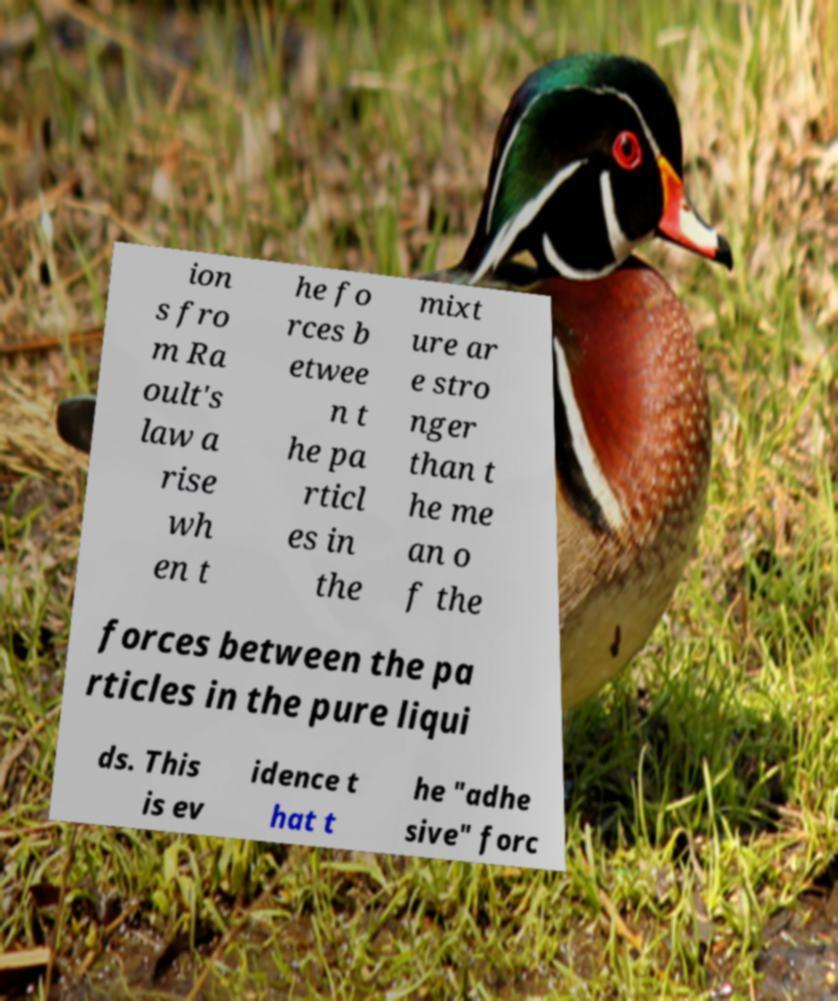Please identify and transcribe the text found in this image. ion s fro m Ra oult's law a rise wh en t he fo rces b etwee n t he pa rticl es in the mixt ure ar e stro nger than t he me an o f the forces between the pa rticles in the pure liqui ds. This is ev idence t hat t he "adhe sive" forc 